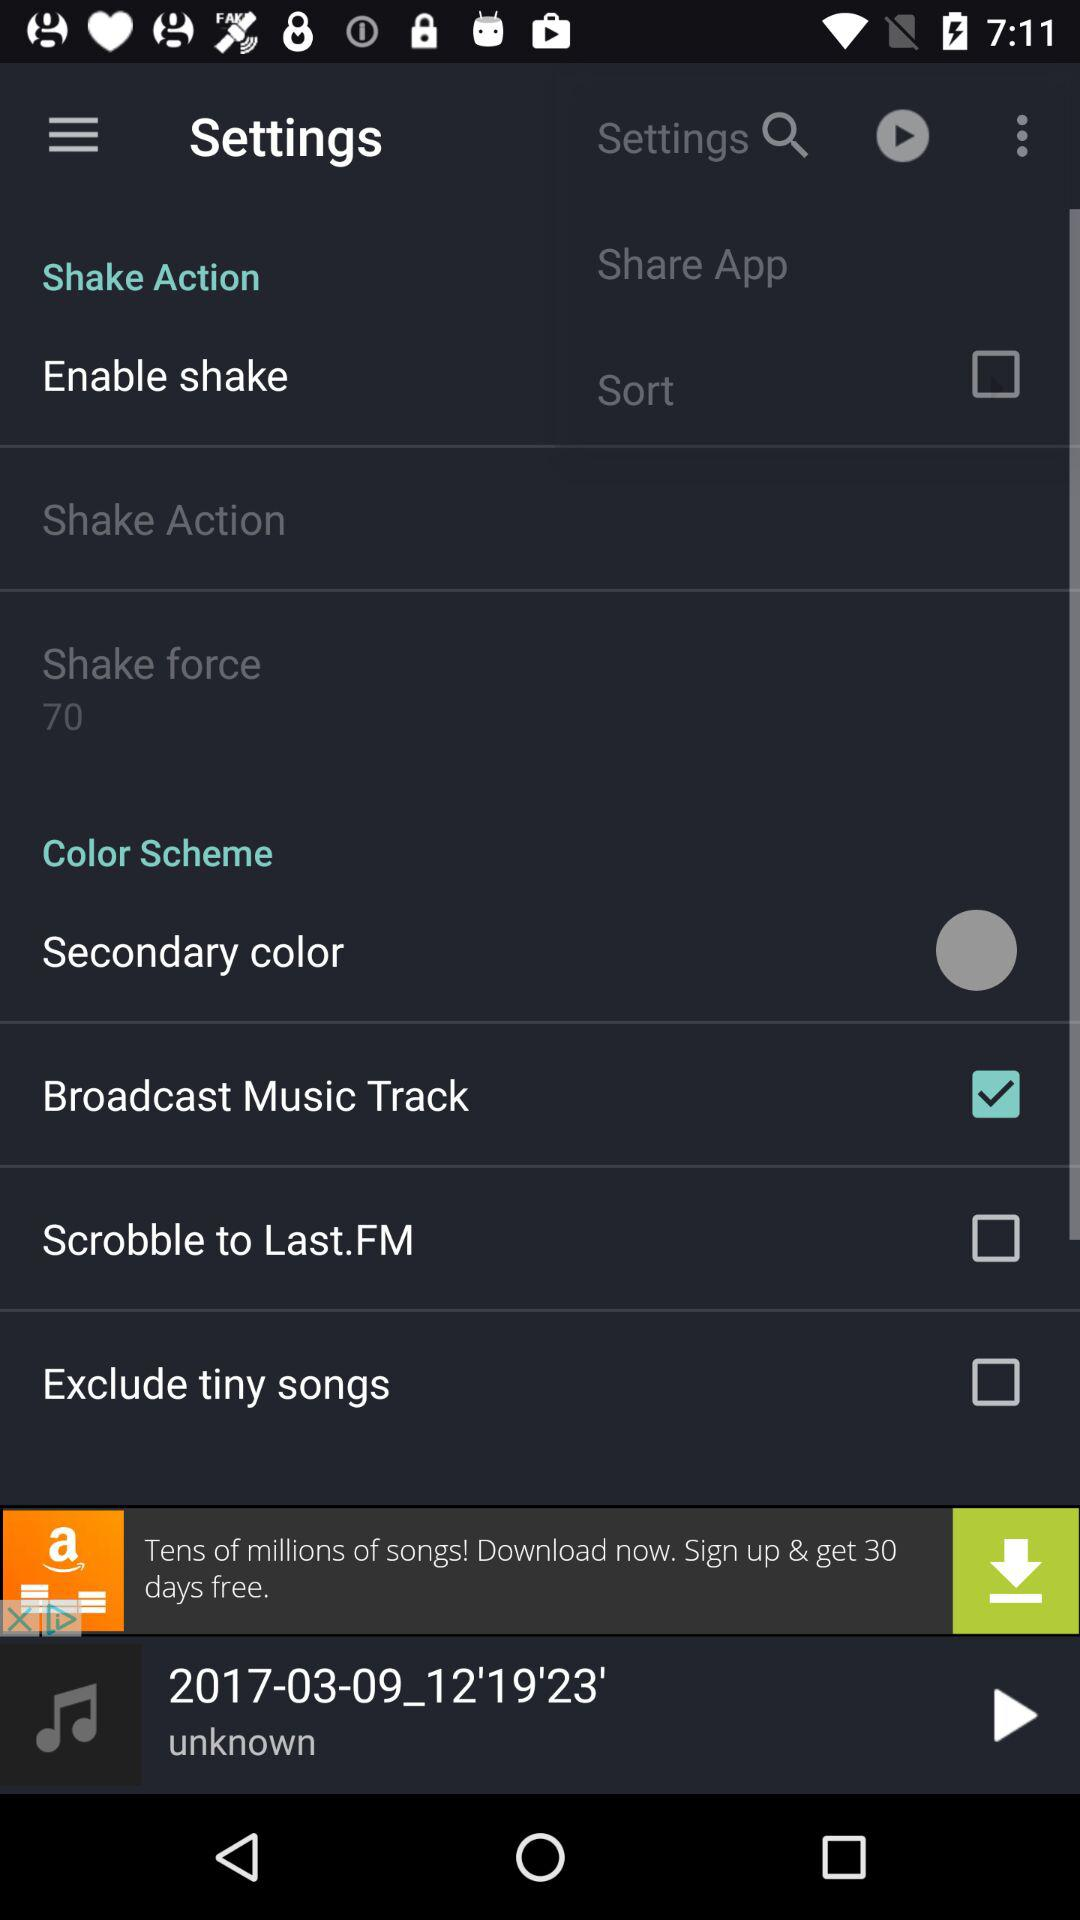What is the status of the "Broadcast Music Track"? The status is on. 